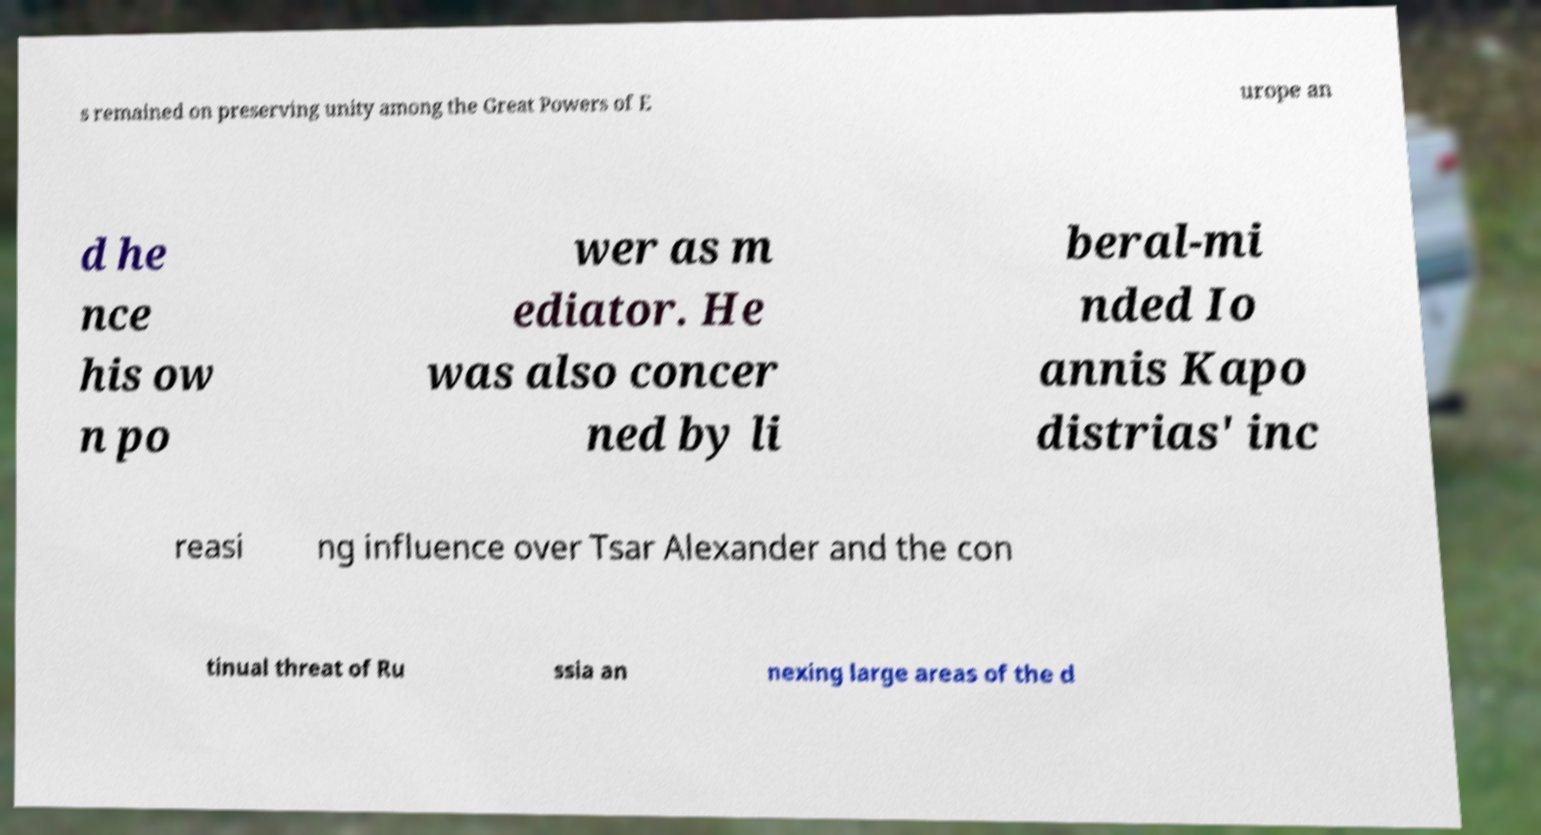Could you extract and type out the text from this image? s remained on preserving unity among the Great Powers of E urope an d he nce his ow n po wer as m ediator. He was also concer ned by li beral-mi nded Io annis Kapo distrias' inc reasi ng influence over Tsar Alexander and the con tinual threat of Ru ssia an nexing large areas of the d 